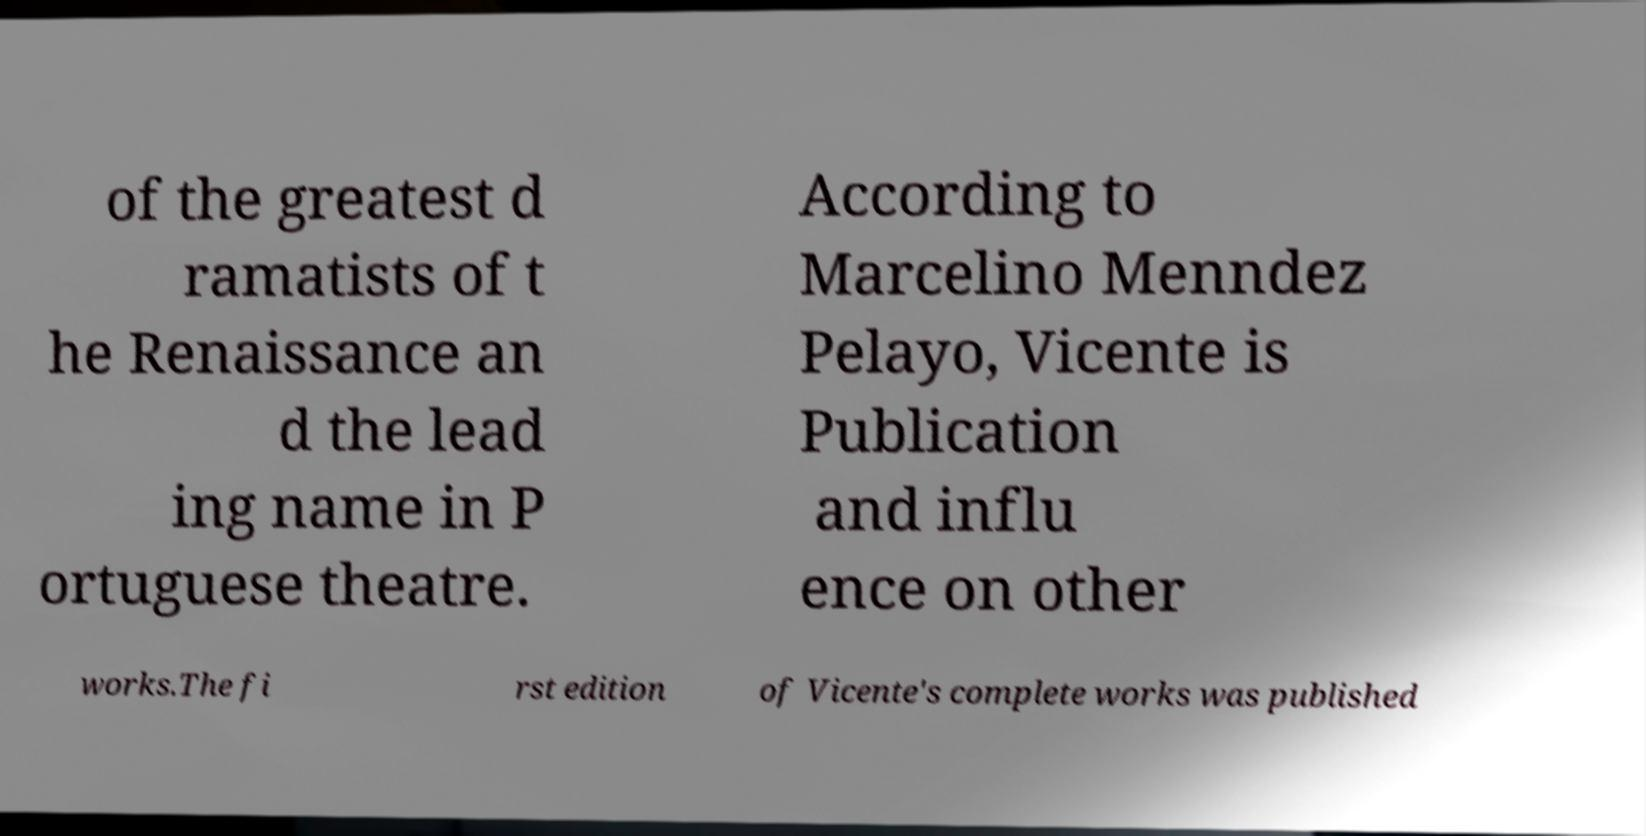There's text embedded in this image that I need extracted. Can you transcribe it verbatim? of the greatest d ramatists of t he Renaissance an d the lead ing name in P ortuguese theatre. According to Marcelino Menndez Pelayo, Vicente is Publication and influ ence on other works.The fi rst edition of Vicente's complete works was published 